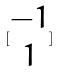Convert formula to latex. <formula><loc_0><loc_0><loc_500><loc_500>[ \begin{matrix} - 1 \\ 1 \end{matrix} ]</formula> 